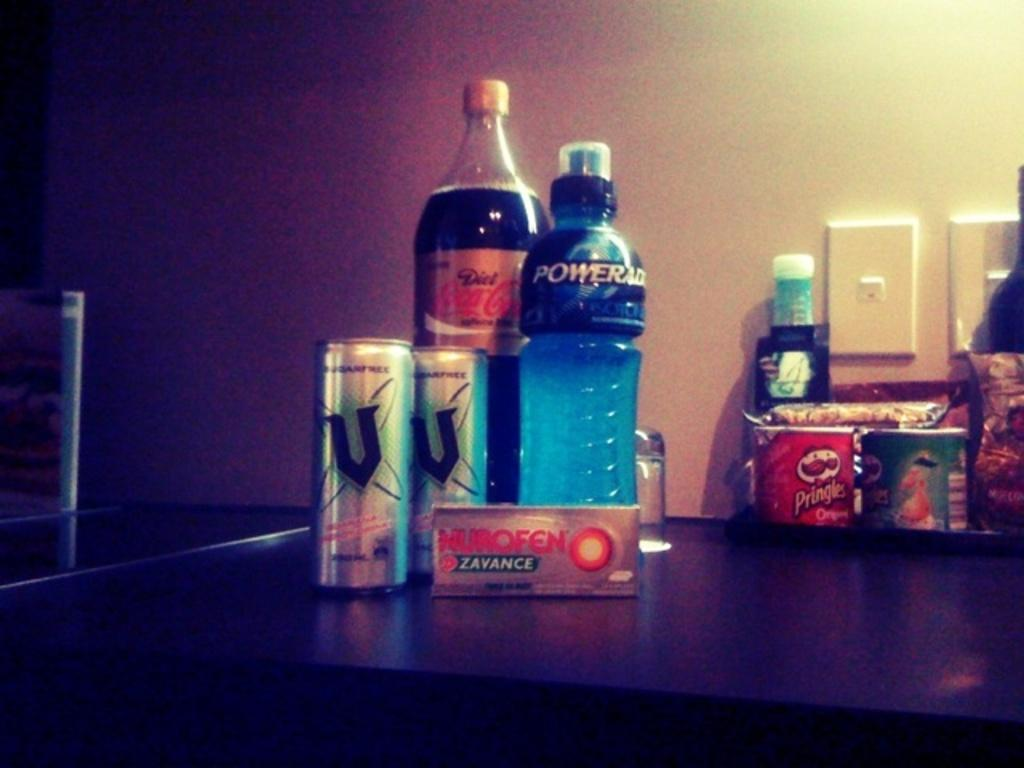<image>
Summarize the visual content of the image. Bottle and cans on a counter with a black V on it. 